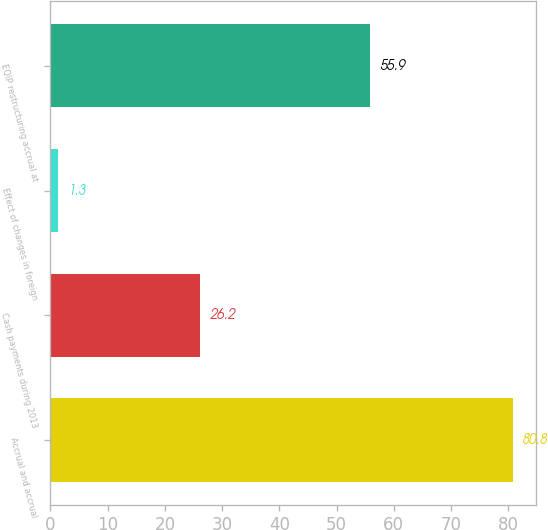<chart> <loc_0><loc_0><loc_500><loc_500><bar_chart><fcel>Accrual and accrual<fcel>Cash payments during 2013<fcel>Effect of changes in foreign<fcel>EQIP restructuring accrual at<nl><fcel>80.8<fcel>26.2<fcel>1.3<fcel>55.9<nl></chart> 